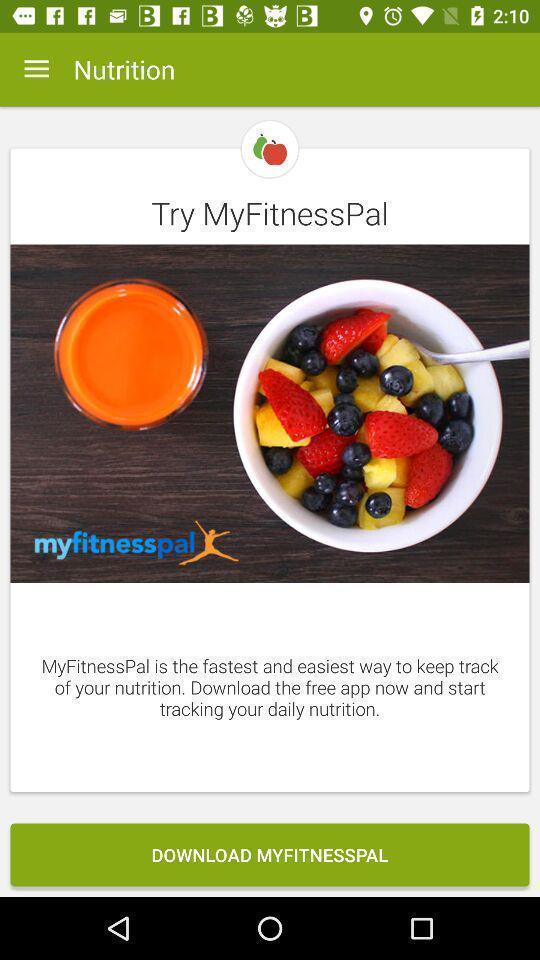Summarize the information in this screenshot. Window displaying a fitness app. 